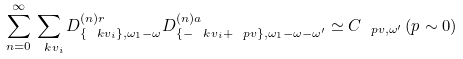Convert formula to latex. <formula><loc_0><loc_0><loc_500><loc_500>\sum _ { n = 0 } ^ { \infty } \sum _ { \ k v _ { i } } { D ^ { ( n ) r } _ { \{ \ k v _ { i } \} , \omega _ { 1 } - \omega } } { D ^ { ( n ) a } _ { \{ - \ k v _ { i } + \ p v \} , \omega _ { 1 } - \omega - \omega ^ { \prime } } } \simeq C _ { \ p v , \omega ^ { \prime } } \, ( p \sim 0 )</formula> 